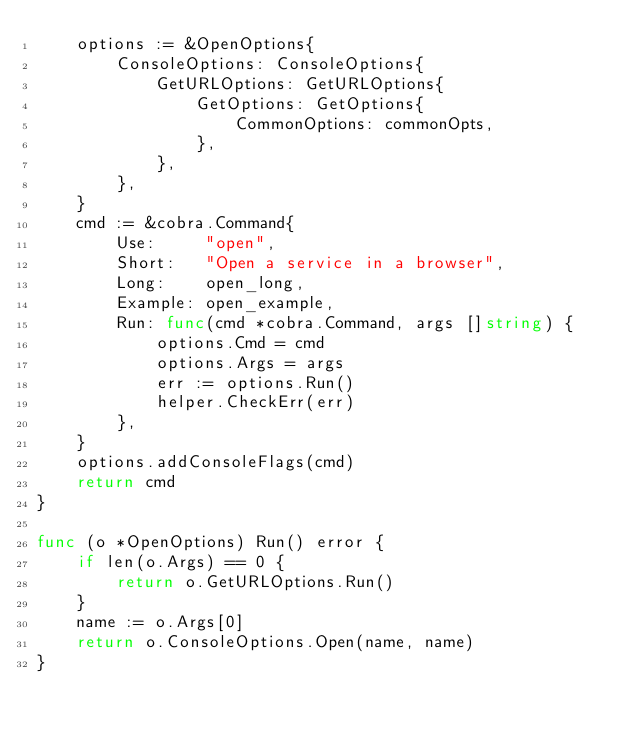Convert code to text. <code><loc_0><loc_0><loc_500><loc_500><_Go_>	options := &OpenOptions{
		ConsoleOptions: ConsoleOptions{
			GetURLOptions: GetURLOptions{
				GetOptions: GetOptions{
					CommonOptions: commonOpts,
				},
			},
		},
	}
	cmd := &cobra.Command{
		Use:     "open",
		Short:   "Open a service in a browser",
		Long:    open_long,
		Example: open_example,
		Run: func(cmd *cobra.Command, args []string) {
			options.Cmd = cmd
			options.Args = args
			err := options.Run()
			helper.CheckErr(err)
		},
	}
	options.addConsoleFlags(cmd)
	return cmd
}

func (o *OpenOptions) Run() error {
	if len(o.Args) == 0 {
		return o.GetURLOptions.Run()
	}
	name := o.Args[0]
	return o.ConsoleOptions.Open(name, name)
}
</code> 